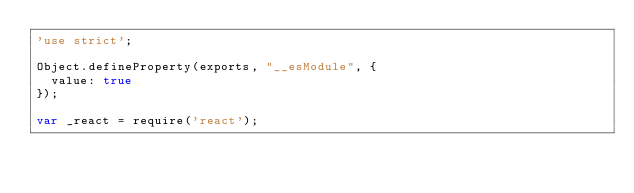<code> <loc_0><loc_0><loc_500><loc_500><_JavaScript_>'use strict';

Object.defineProperty(exports, "__esModule", {
  value: true
});

var _react = require('react');
</code> 